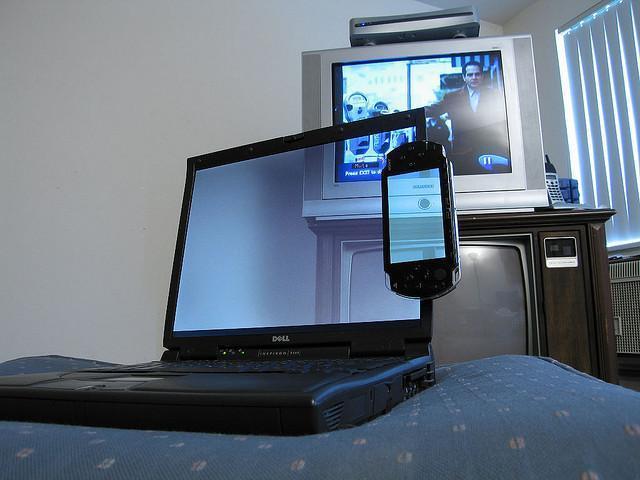How many screens are shown?
Give a very brief answer. 4. How many tvs are there?
Give a very brief answer. 2. 